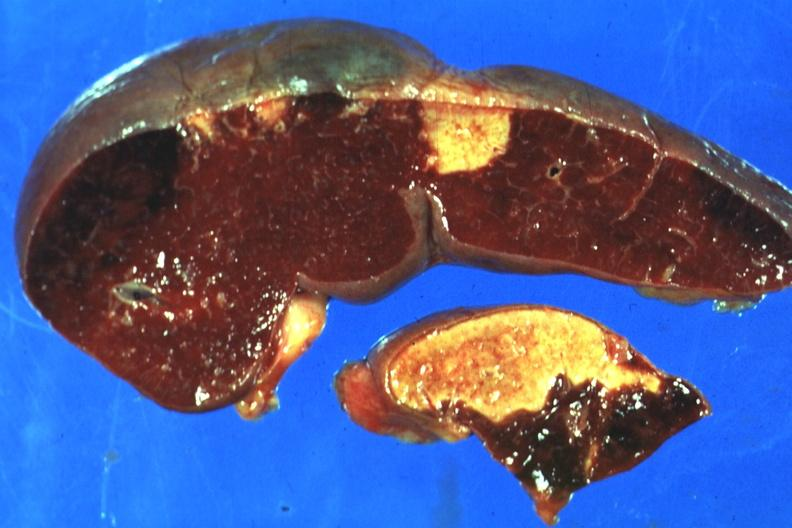s heel ulcer present?
Answer the question using a single word or phrase. No 